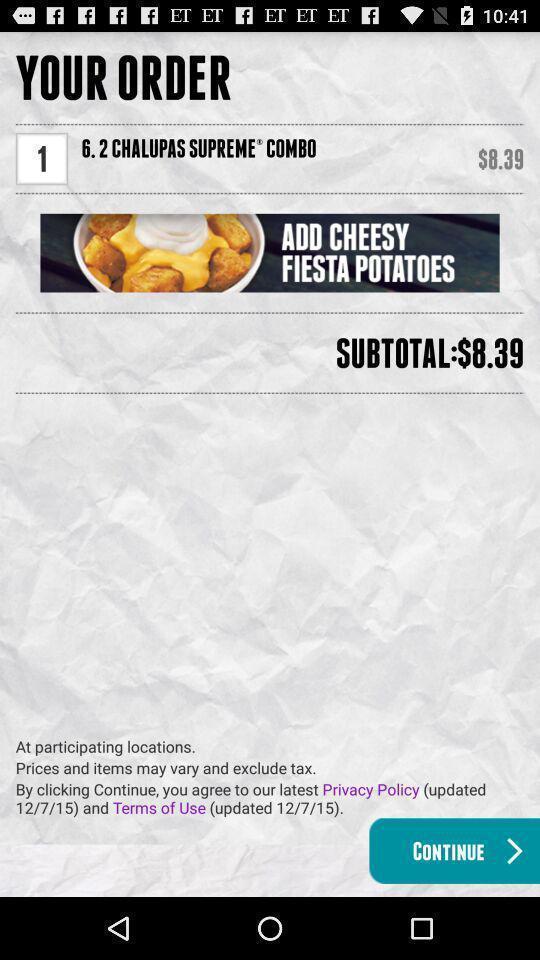Explain the elements present in this screenshot. Screen displaying my order details on food app. 